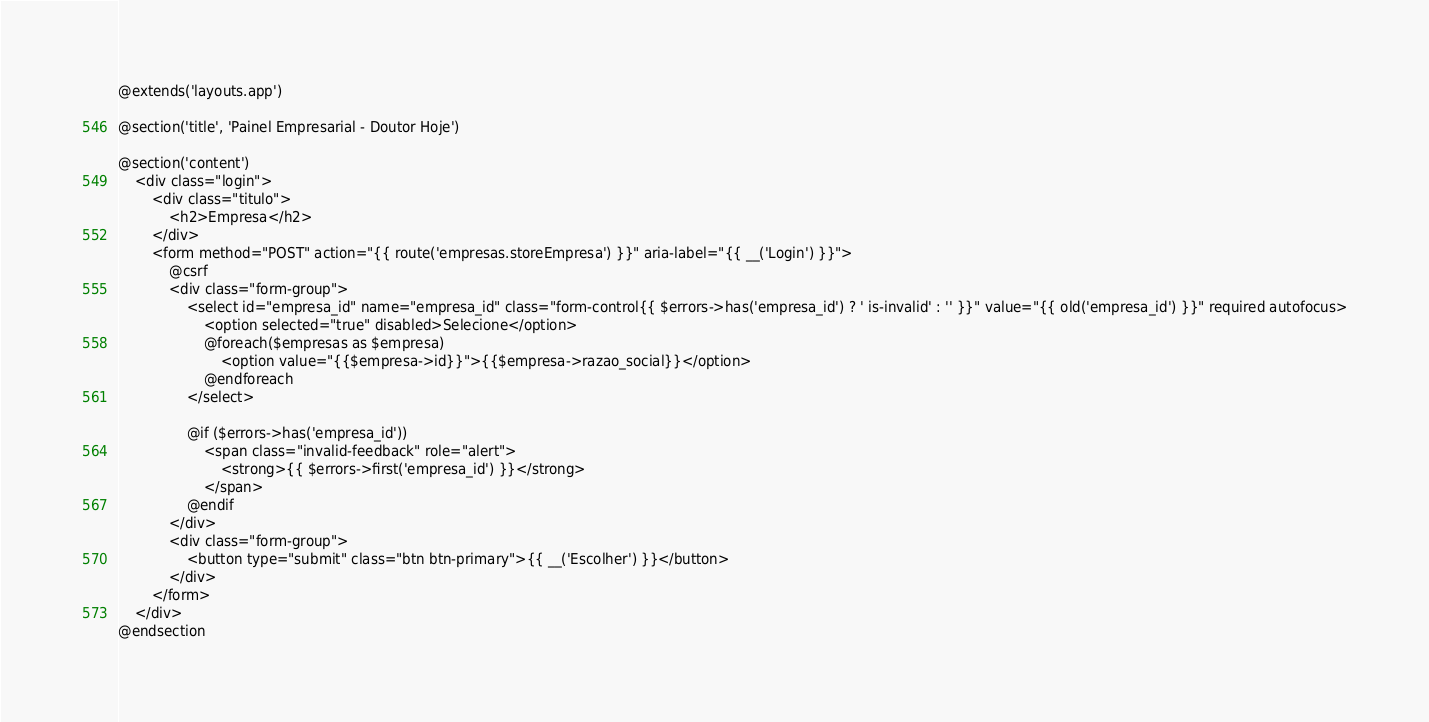<code> <loc_0><loc_0><loc_500><loc_500><_PHP_>@extends('layouts.app')

@section('title', 'Painel Empresarial - Doutor Hoje')

@section('content')
	<div class="login">
		<div class="titulo">
			<h2>Empresa</h2>
		</div>
		<form method="POST" action="{{ route('empresas.storeEmpresa') }}" aria-label="{{ __('Login') }}">
			@csrf
			<div class="form-group">
				<select id="empresa_id" name="empresa_id" class="form-control{{ $errors->has('empresa_id') ? ' is-invalid' : '' }}" value="{{ old('empresa_id') }}" required autofocus>
					<option selected="true" disabled>Selecione</option>
					@foreach($empresas as $empresa)
						<option value="{{$empresa->id}}">{{$empresa->razao_social}}</option>
					@endforeach
				</select>

				@if ($errors->has('empresa_id'))
					<span class="invalid-feedback" role="alert">
						<strong>{{ $errors->first('empresa_id') }}</strong>
					</span>
				@endif
			</div>
			<div class="form-group">
				<button type="submit" class="btn btn-primary">{{ __('Escolher') }}</button>
			</div>
		</form>
	</div>
@endsection

</code> 